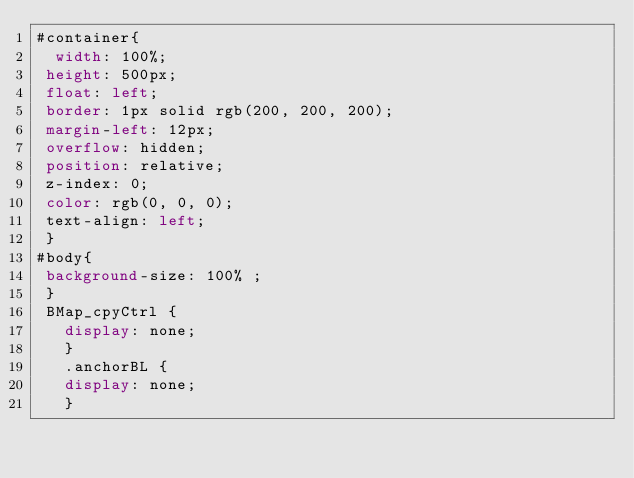<code> <loc_0><loc_0><loc_500><loc_500><_CSS_>#container{
	width: 100%;
 height: 500px;
 float: left; 
 border: 1px solid rgb(200, 200, 200); 
 margin-left: 12px; 
 overflow: hidden; 
 position: relative; 
 z-index: 0; 
 color: rgb(0, 0, 0); 
 text-align: left;
 }
#body{
 background-size: 100% ;
 }
 BMap_cpyCtrl {
	 display: none;
	 }
	 .anchorBL {
	 display: none;
	 }</code> 